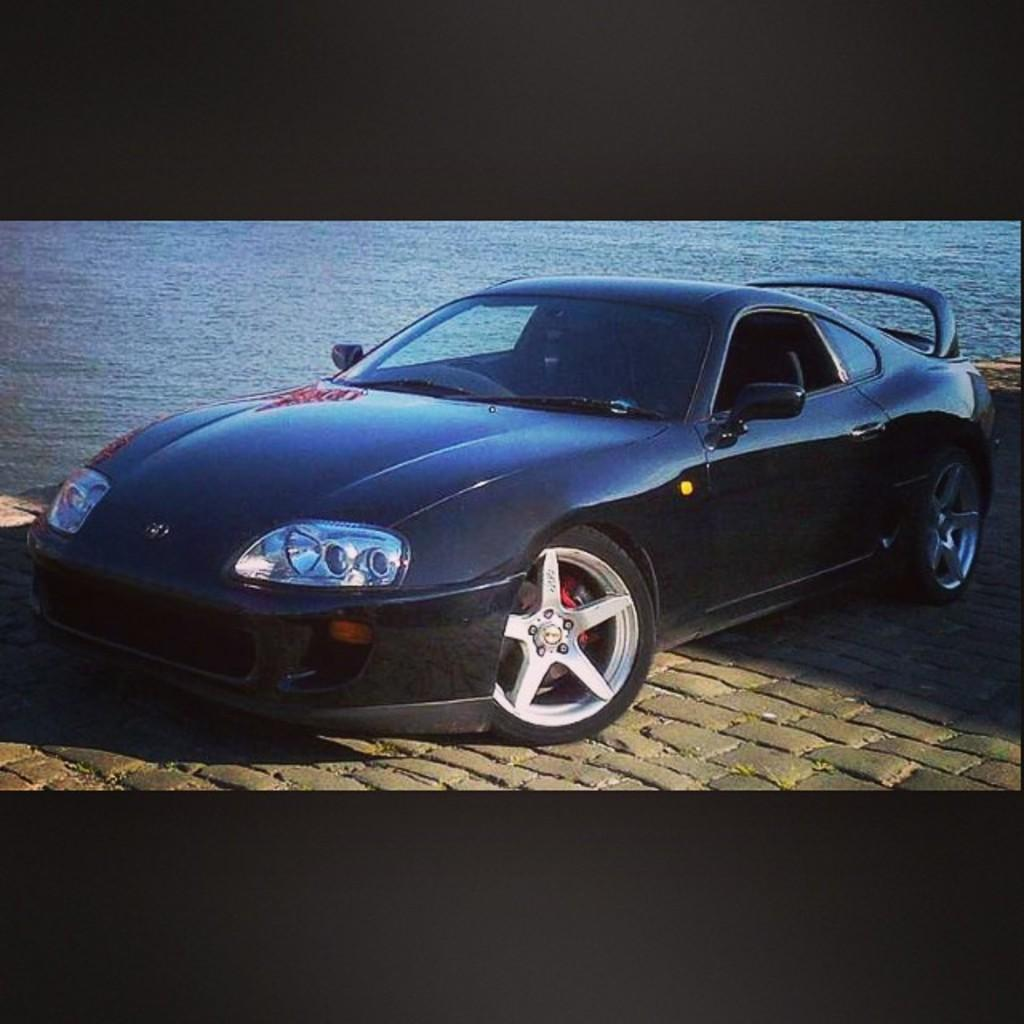What color is the car in the image? The car in the image is black. Where is the car located in the image? The car is in the front of the image. What can be seen in the background of the image? There is water visible in the background of the image. How many ears can be seen on the car in the image? There are no ears visible on the car in the image, as cars do not have ears. 